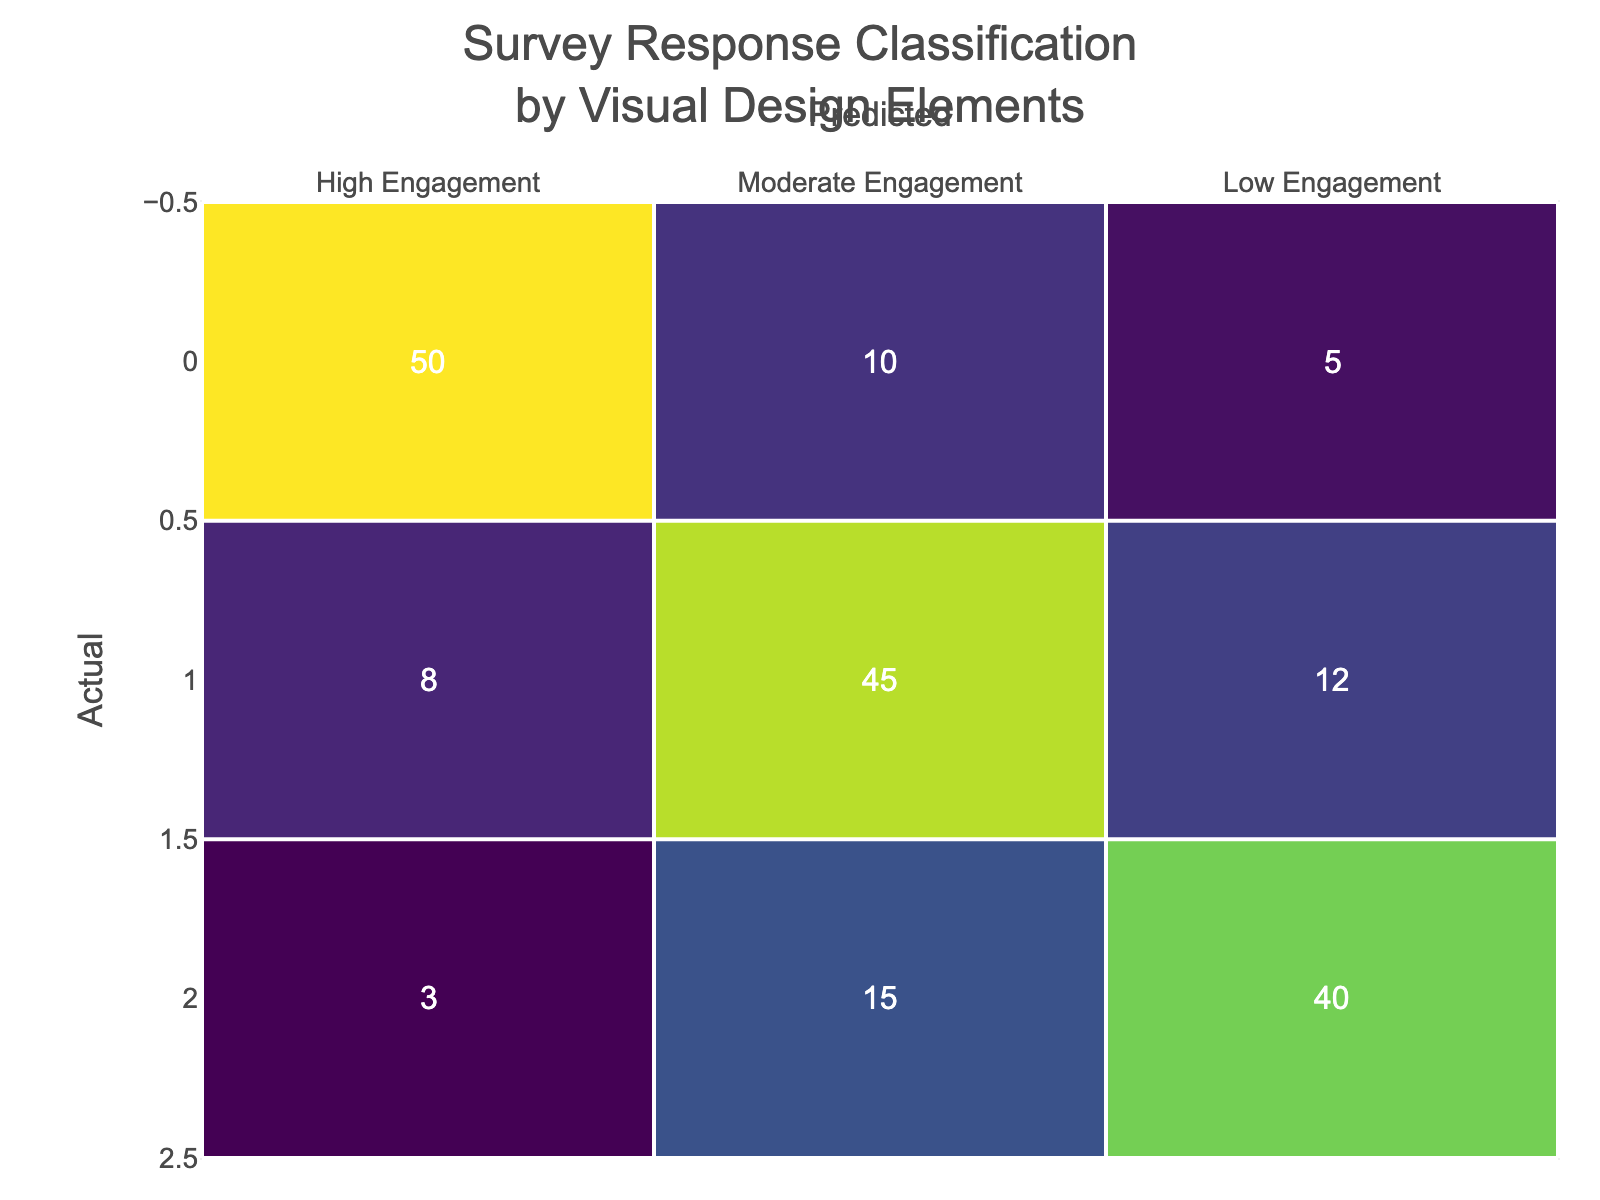What is the number of actual High Engagement responses predicted as Low Engagement? From the table, we can find the cell in the "High Engagement" row and "Low Engagement" column, which shows the value of 5.
Answer: 5 What was the predicted response for the majority of actual Moderate Engagement cases? To find this, we look at the "Moderate Engagement" row and identify the highest value, which is 45 in the "Moderate Engagement" column.
Answer: Moderate Engagement What is the total number of responses that were predicted as High Engagement? We sum all the values in the "High Engagement" column: (50 + 8 + 3) = 61.
Answer: 61 How many less Low Engagement responses were predicted accurately compared to Moderate Engagement responses? The actual Low Engagement responses predicted as Low Engagement is 40 and for Moderate Engagement is 45. So, the difference is 45 - 40 = 5.
Answer: 5 Was there any case of High Engagement predicted as Moderate Engagement? Yes, looking at the table, we see that there were 10 instances where High Engagement was predicted as Moderate Engagement.
Answer: Yes What percentage of actual High Engagement responses were predicted correctly? The actual High Engagement responses are 50 and the number correctly predicted as High Engagement is also 50. So, the percentage is (50 / 50) * 100 = 100%.
Answer: 100% Based on the predictions, what is the relationship between predicted Low Engagement and actual Moderate Engagement? For actual Moderate Engagement, 12 cases were predicted as Low Engagement. This indicates a misclassification of a portion of Moderate Engagement cases as Low Engagement.
Answer: 12 Out of all the predicted responses, which category had the highest correct predictions? The actual High Engagement responses predicted correctly is 50, Moderate Engagement is 45, and Low Engagement is 40. Therefore, High Engagement had the highest correct predictions.
Answer: High Engagement How many total Low Engagement predictions were there? To find the total, we sum the values in the Low Engagement column: (5 + 12 + 40) = 57.
Answer: 57 